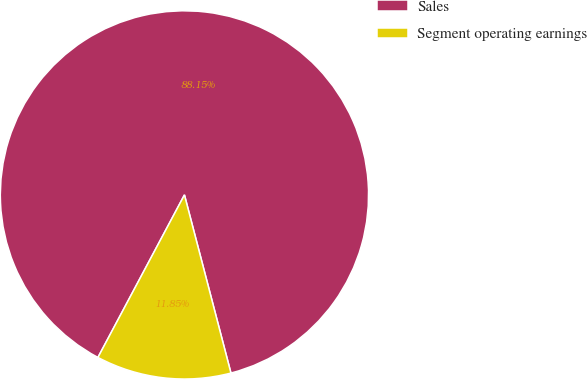Convert chart to OTSL. <chart><loc_0><loc_0><loc_500><loc_500><pie_chart><fcel>Sales<fcel>Segment operating earnings<nl><fcel>88.15%<fcel>11.85%<nl></chart> 